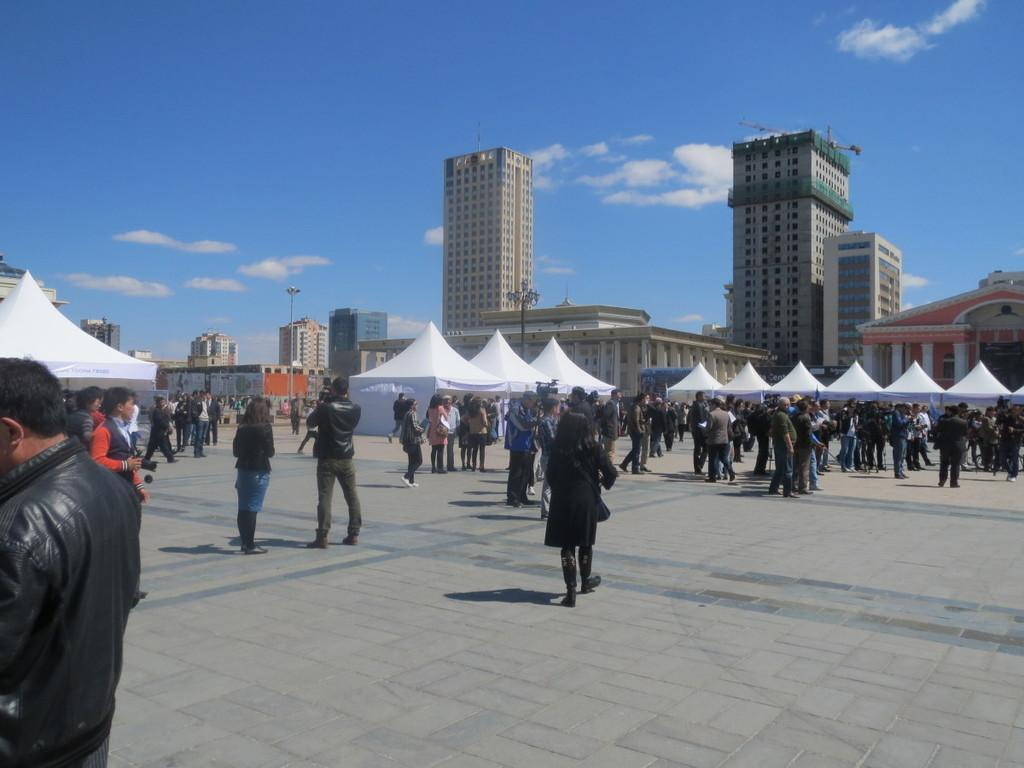What are the people in the image doing? The people in the image are walking on the land. What can be seen in the background of the image? There are tents and buildings in the background of the image. What is visible in the sky in the image? There are clouds visible in the sky. What type of pies are being served in the image? There are no pies present in the image. What is the acoustics like in the image? The provided facts do not give any information about the acoustics in the image. 